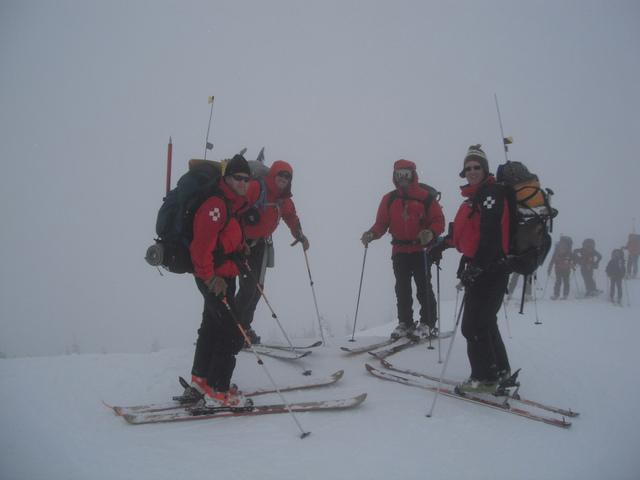What brand are their jackets?
Give a very brief answer. North face. How many men are riding skis?
Short answer required. 4. What kind of weather are they having in this picture?
Write a very short answer. Snowy. Is it snowing?
Write a very short answer. Yes. Are there any women in the group?
Answer briefly. No. What color ski jackets are they wearing?
Keep it brief. Red. Is it a sunny day?
Quick response, please. No. 